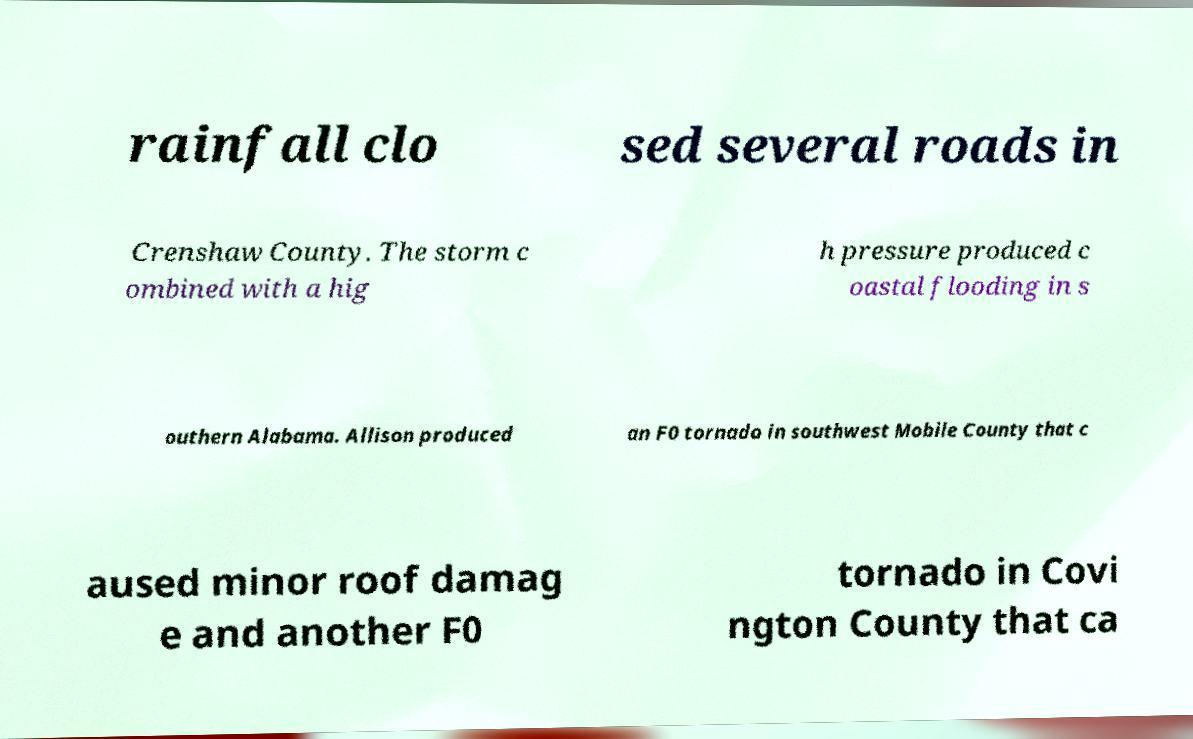Could you assist in decoding the text presented in this image and type it out clearly? rainfall clo sed several roads in Crenshaw County. The storm c ombined with a hig h pressure produced c oastal flooding in s outhern Alabama. Allison produced an F0 tornado in southwest Mobile County that c aused minor roof damag e and another F0 tornado in Covi ngton County that ca 